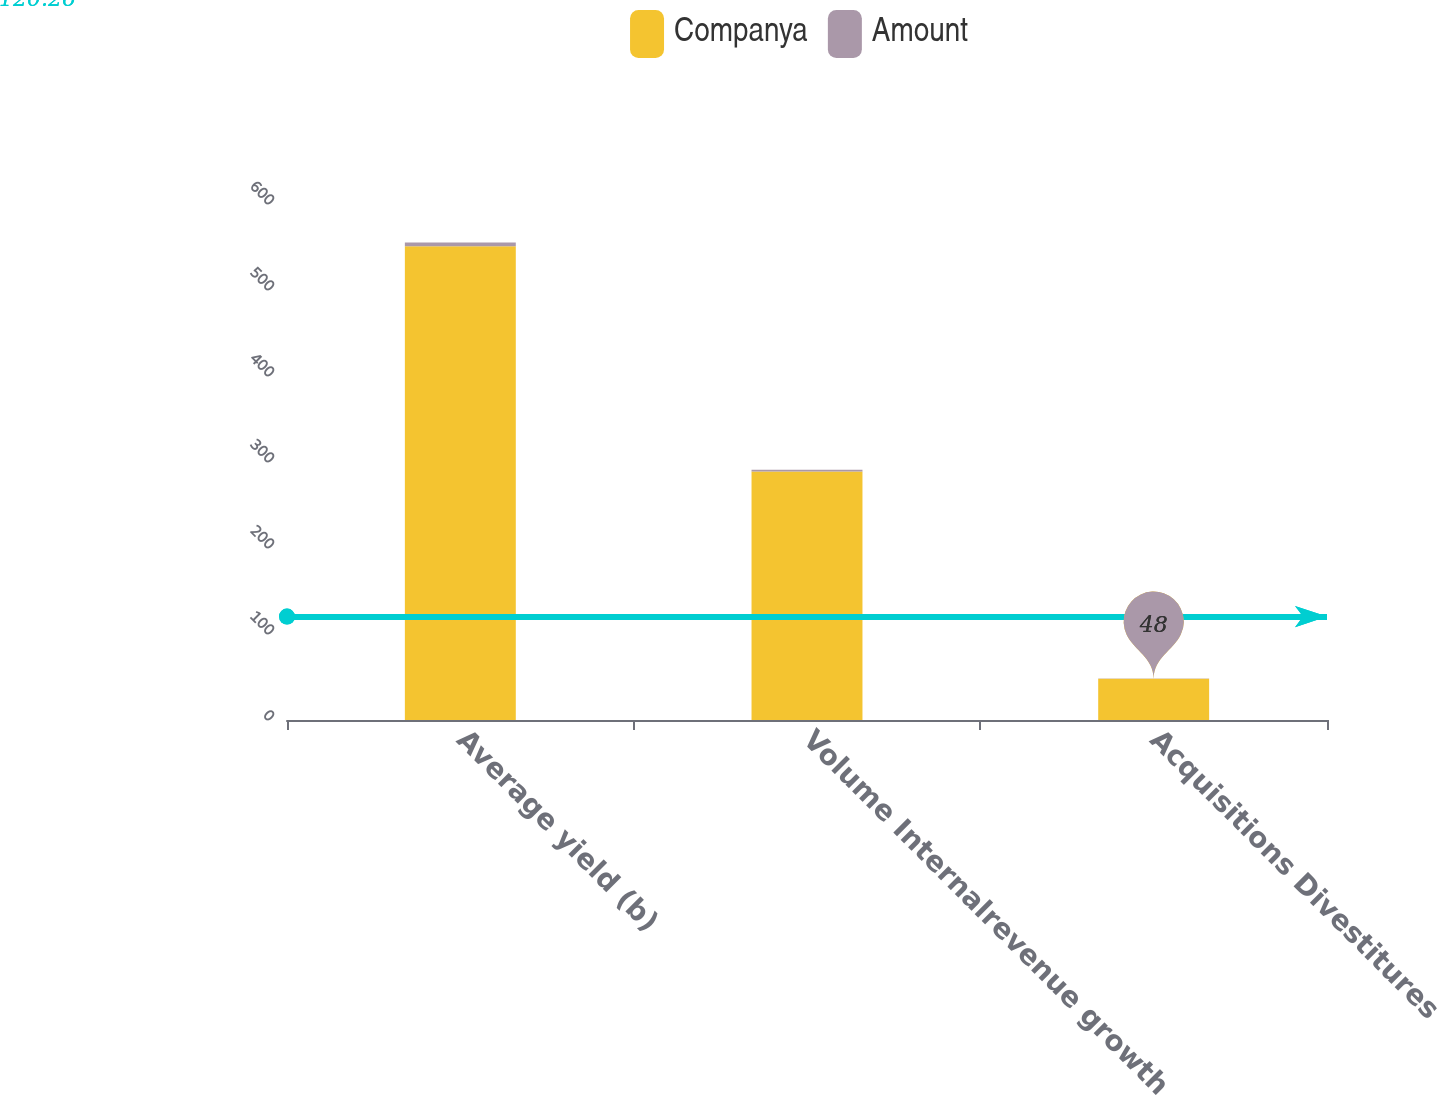<chart> <loc_0><loc_0><loc_500><loc_500><stacked_bar_chart><ecel><fcel>Average yield (b)<fcel>Volume Internalrevenue growth<fcel>Acquisitions Divestitures<nl><fcel>Companya<fcel>551<fcel>289<fcel>48<nl><fcel>Amount<fcel>4.1<fcel>2.1<fcel>0.3<nl></chart> 